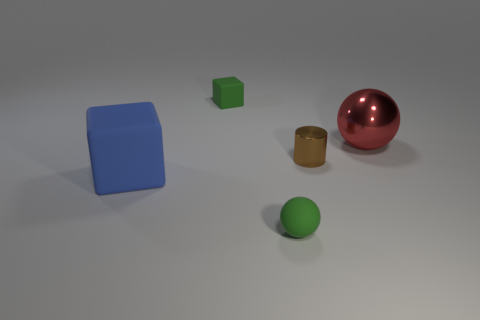Add 1 large blue blocks. How many objects exist? 6 Subtract all spheres. How many objects are left? 3 Subtract 1 spheres. How many spheres are left? 1 Subtract all brown cubes. How many blue cylinders are left? 0 Add 4 red shiny objects. How many red shiny objects are left? 5 Add 3 red metal objects. How many red metal objects exist? 4 Subtract 0 green cylinders. How many objects are left? 5 Subtract all purple cubes. Subtract all red cylinders. How many cubes are left? 2 Subtract all red balls. Subtract all rubber balls. How many objects are left? 3 